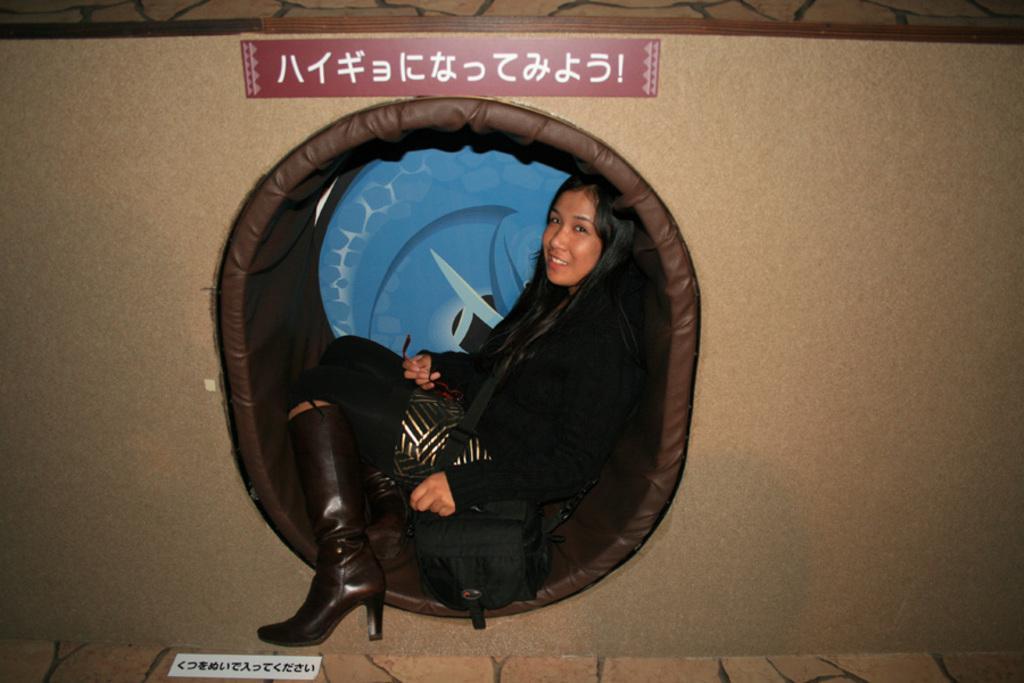Could you give a brief overview of what you see in this image? In this image there is a woman sitting with a smile on her face and there is a wall. 